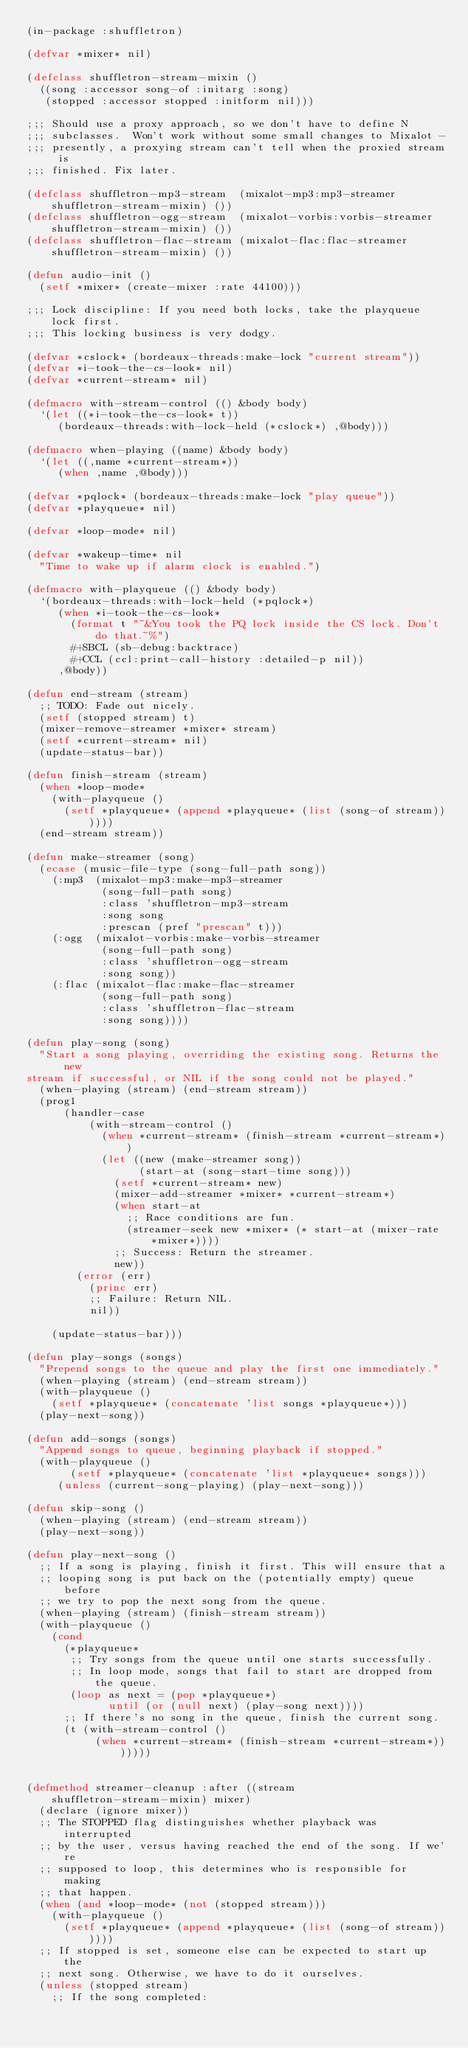<code> <loc_0><loc_0><loc_500><loc_500><_Lisp_>(in-package :shuffletron)

(defvar *mixer* nil)

(defclass shuffletron-stream-mixin ()
  ((song :accessor song-of :initarg :song)
   (stopped :accessor stopped :initform nil)))

;;; Should use a proxy approach, so we don't have to define N
;;; subclasses.  Won't work without some small changes to Mixalot -
;;; presently, a proxying stream can't tell when the proxied stream is
;;; finished. Fix later.

(defclass shuffletron-mp3-stream  (mixalot-mp3:mp3-streamer shuffletron-stream-mixin) ())
(defclass shuffletron-ogg-stream  (mixalot-vorbis:vorbis-streamer shuffletron-stream-mixin) ())
(defclass shuffletron-flac-stream (mixalot-flac:flac-streamer shuffletron-stream-mixin) ())

(defun audio-init ()
  (setf *mixer* (create-mixer :rate 44100)))

;;; Lock discipline: If you need both locks, take the playqueue lock first.
;;; This locking business is very dodgy.

(defvar *cslock* (bordeaux-threads:make-lock "current stream"))
(defvar *i-took-the-cs-look* nil)
(defvar *current-stream* nil)

(defmacro with-stream-control (() &body body)
  `(let ((*i-took-the-cs-look* t))
     (bordeaux-threads:with-lock-held (*cslock*) ,@body)))

(defmacro when-playing ((name) &body body)
  `(let ((,name *current-stream*))
     (when ,name ,@body)))

(defvar *pqlock* (bordeaux-threads:make-lock "play queue"))
(defvar *playqueue* nil)

(defvar *loop-mode* nil)

(defvar *wakeup-time* nil
  "Time to wake up if alarm clock is enabled.")

(defmacro with-playqueue (() &body body)
  `(bordeaux-threads:with-lock-held (*pqlock*)
     (when *i-took-the-cs-look*
       (format t "~&You took the PQ lock inside the CS lock. Don't do that.~%")
       #+SBCL (sb-debug:backtrace)
       #+CCL (ccl:print-call-history :detailed-p nil))
     ,@body))

(defun end-stream (stream)
  ;; TODO: Fade out nicely.
  (setf (stopped stream) t)
  (mixer-remove-streamer *mixer* stream)
  (setf *current-stream* nil)
  (update-status-bar))

(defun finish-stream (stream)
  (when *loop-mode*
    (with-playqueue ()
      (setf *playqueue* (append *playqueue* (list (song-of stream))))))
  (end-stream stream))

(defun make-streamer (song)
  (ecase (music-file-type (song-full-path song))
    (:mp3  (mixalot-mp3:make-mp3-streamer
            (song-full-path song)
            :class 'shuffletron-mp3-stream
            :song song
            :prescan (pref "prescan" t)))
    (:ogg  (mixalot-vorbis:make-vorbis-streamer
            (song-full-path song)
            :class 'shuffletron-ogg-stream
            :song song))
    (:flac (mixalot-flac:make-flac-streamer
            (song-full-path song)
            :class 'shuffletron-flac-stream
            :song song))))

(defun play-song (song)
  "Start a song playing, overriding the existing song. Returns the new
stream if successful, or NIL if the song could not be played."
  (when-playing (stream) (end-stream stream))
  (prog1
      (handler-case
          (with-stream-control ()
            (when *current-stream* (finish-stream *current-stream*))
            (let ((new (make-streamer song))
                  (start-at (song-start-time song)))
              (setf *current-stream* new)
              (mixer-add-streamer *mixer* *current-stream*)
              (when start-at
                ;; Race conditions are fun.
                (streamer-seek new *mixer* (* start-at (mixer-rate *mixer*))))
              ;; Success: Return the streamer.
              new))
        (error (err)
          (princ err)
          ;; Failure: Return NIL.
          nil))

    (update-status-bar)))

(defun play-songs (songs)
  "Prepend songs to the queue and play the first one immediately."
  (when-playing (stream) (end-stream stream))
  (with-playqueue ()
    (setf *playqueue* (concatenate 'list songs *playqueue*)))
  (play-next-song))

(defun add-songs (songs)
  "Append songs to queue, beginning playback if stopped."
  (with-playqueue ()
       (setf *playqueue* (concatenate 'list *playqueue* songs)))
     (unless (current-song-playing) (play-next-song)))

(defun skip-song ()
  (when-playing (stream) (end-stream stream))
  (play-next-song))

(defun play-next-song ()
  ;; If a song is playing, finish it first. This will ensure that a
  ;; looping song is put back on the (potentially empty) queue before
  ;; we try to pop the next song from the queue.
  (when-playing (stream) (finish-stream stream))
  (with-playqueue ()
    (cond
      (*playqueue*
       ;; Try songs from the queue until one starts successfully.
       ;; In loop mode, songs that fail to start are dropped from the queue.
       (loop as next = (pop *playqueue*)
             until (or (null next) (play-song next))))
      ;; If there's no song in the queue, finish the current song.
      (t (with-stream-control ()
           (when *current-stream* (finish-stream *current-stream*)))))))


(defmethod streamer-cleanup :after ((stream shuffletron-stream-mixin) mixer)
  (declare (ignore mixer))
  ;; The STOPPED flag distinguishes whether playback was interrupted
  ;; by the user, versus having reached the end of the song. If we're
  ;; supposed to loop, this determines who is responsible for making
  ;; that happen.
  (when (and *loop-mode* (not (stopped stream)))
    (with-playqueue ()
      (setf *playqueue* (append *playqueue* (list (song-of stream))))))
  ;; If stopped is set, someone else can be expected to start up the
  ;; next song. Otherwise, we have to do it ourselves.
  (unless (stopped stream)
    ;; If the song completed:</code> 